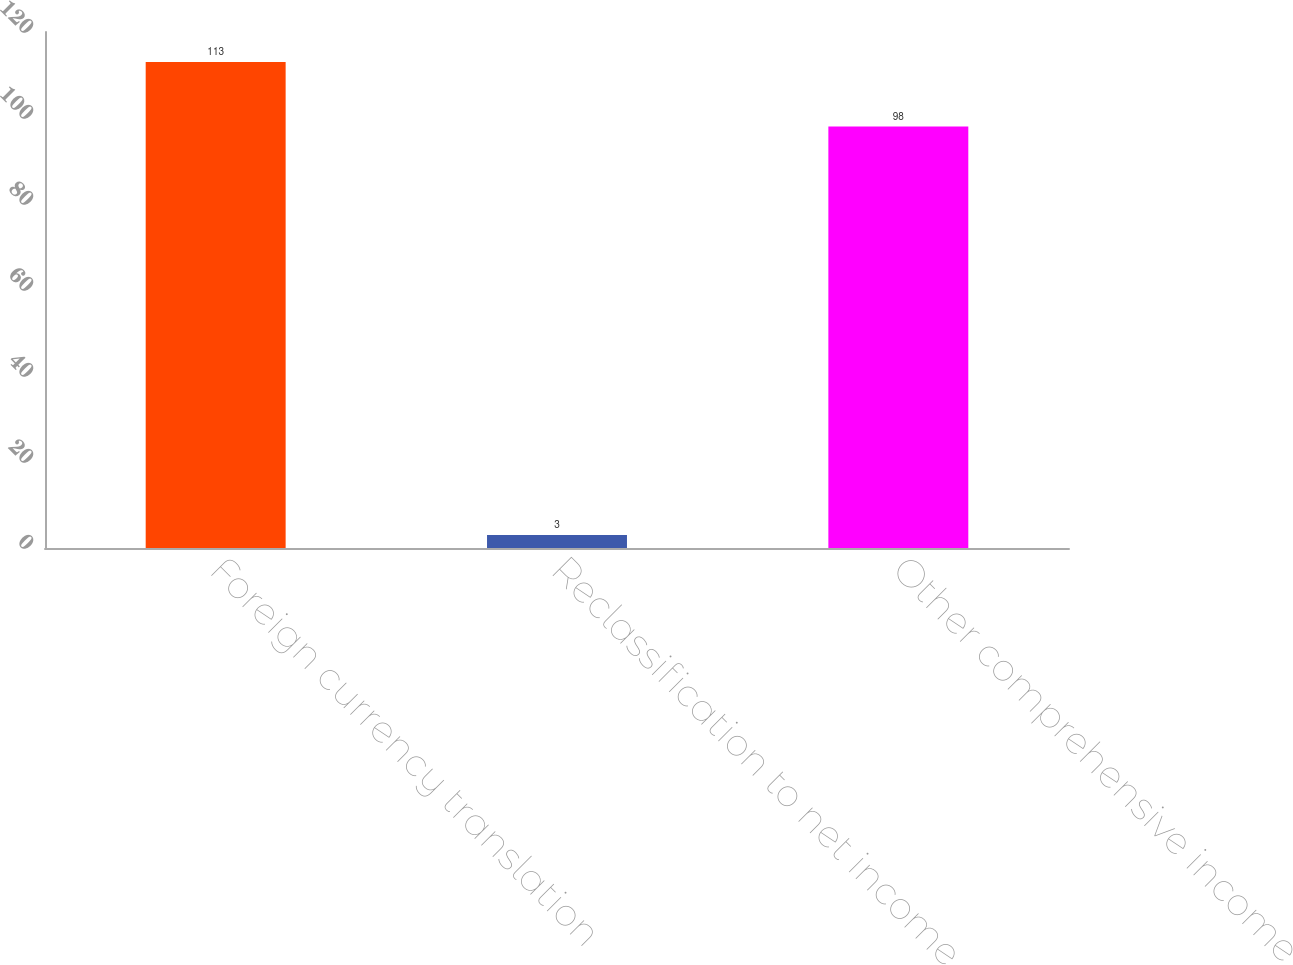Convert chart to OTSL. <chart><loc_0><loc_0><loc_500><loc_500><bar_chart><fcel>Foreign currency translation<fcel>Reclassification to net income<fcel>Other comprehensive income<nl><fcel>113<fcel>3<fcel>98<nl></chart> 